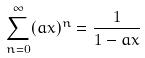Convert formula to latex. <formula><loc_0><loc_0><loc_500><loc_500>\sum _ { n = 0 } ^ { \infty } ( a x ) ^ { n } = \frac { 1 } { 1 - a x }</formula> 